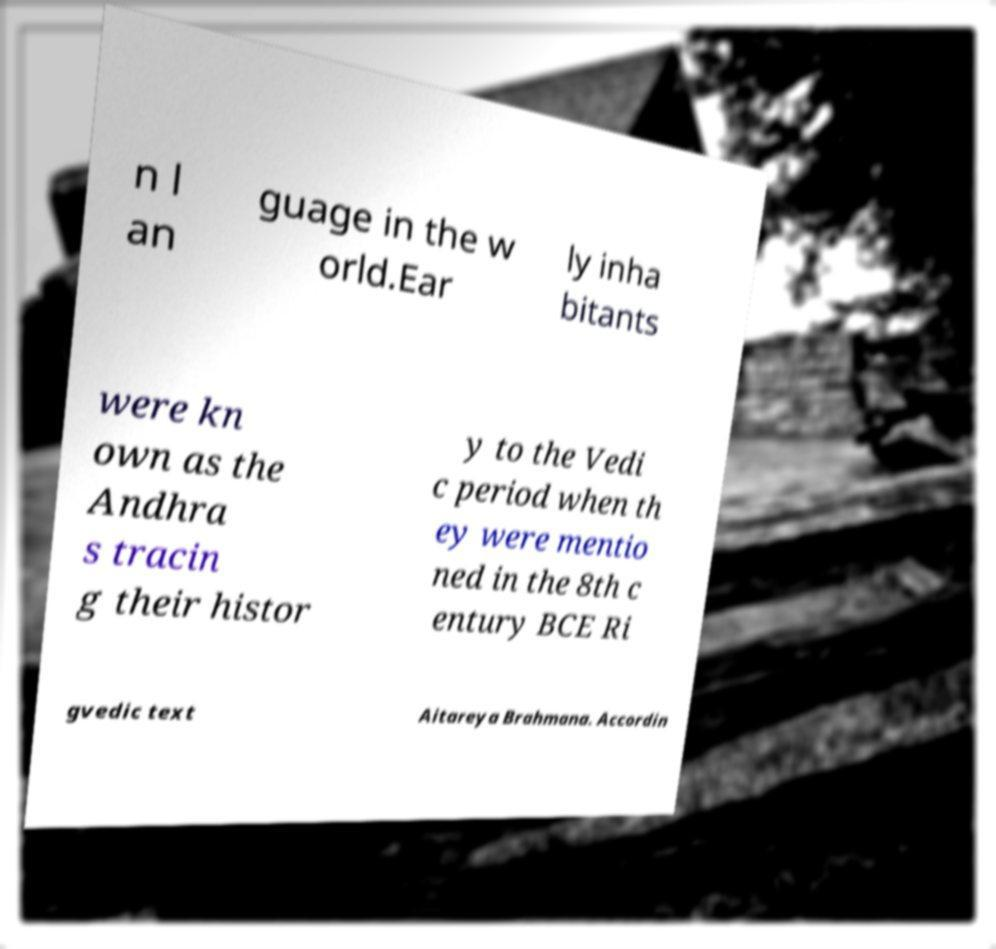What messages or text are displayed in this image? I need them in a readable, typed format. n l an guage in the w orld.Ear ly inha bitants were kn own as the Andhra s tracin g their histor y to the Vedi c period when th ey were mentio ned in the 8th c entury BCE Ri gvedic text Aitareya Brahmana. Accordin 